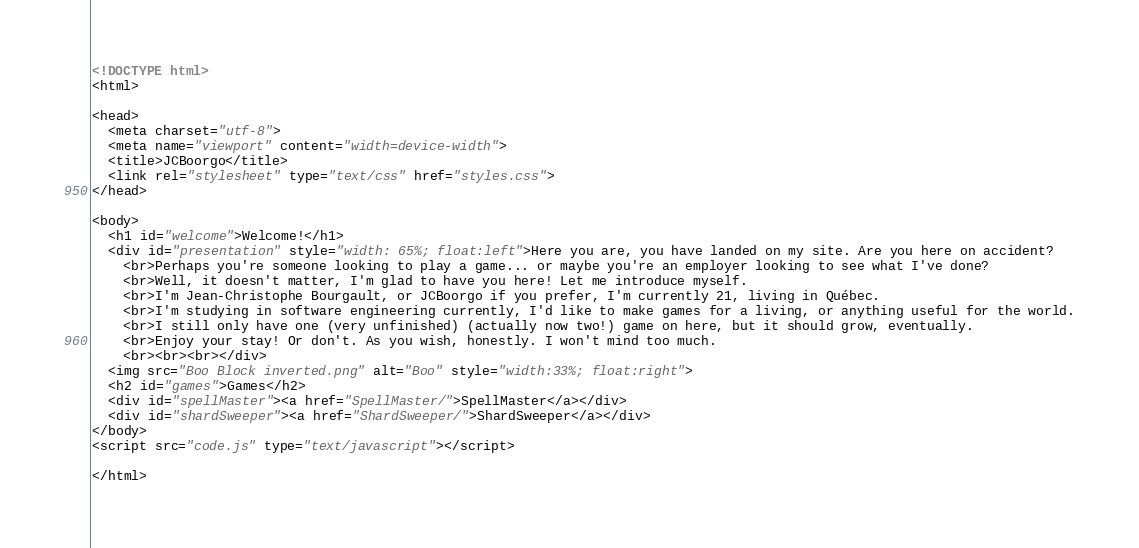Convert code to text. <code><loc_0><loc_0><loc_500><loc_500><_HTML_><!DOCTYPE html>
<html>

<head>
  <meta charset="utf-8">
  <meta name="viewport" content="width=device-width">
  <title>JCBoorgo</title>
  <link rel="stylesheet" type="text/css" href="styles.css">
</head>

<body>
  <h1 id="welcome">Welcome!</h1>
  <div id="presentation" style="width: 65%; float:left">Here you are, you have landed on my site. Are you here on accident?
    <br>Perhaps you're someone looking to play a game... or maybe you're an employer looking to see what I've done?
    <br>Well, it doesn't matter, I'm glad to have you here! Let me introduce myself.
    <br>I'm Jean-Christophe Bourgault, or JCBoorgo if you prefer, I'm currently 21, living in Québec.
    <br>I'm studying in software engineering currently, I'd like to make games for a living, or anything useful for the world.
    <br>I still only have one (very unfinished) (actually now two!) game on here, but it should grow, eventually.
    <br>Enjoy your stay! Or don't. As you wish, honestly. I won't mind too much.
    <br><br><br></div>
  <img src="Boo Block inverted.png" alt="Boo" style="width:33%; float:right">
  <h2 id="games">Games</h2>
  <div id="spellMaster"><a href="SpellMaster/">SpellMaster</a></div>
  <div id="shardSweeper"><a href="ShardSweeper/">ShardSweeper</a></div>
</body>
<script src="code.js" type="text/javascript"></script>

</html>
</code> 